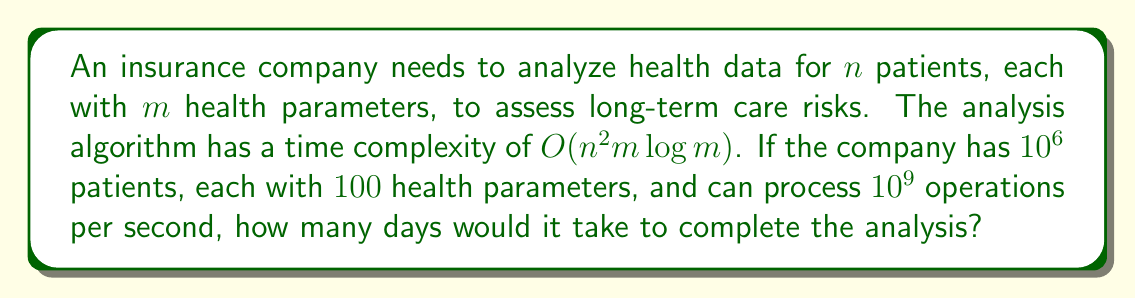Teach me how to tackle this problem. Let's approach this step-by-step:

1) We are given:
   - Number of patients, $n = 10^6$
   - Number of health parameters per patient, $m = 100$
   - Processing speed = $10^9$ operations per second

2) The time complexity is $O(n^2m\log m)$. Let's calculate this:
   
   $$n^2 = (10^6)^2 = 10^{12}$$
   $$m\log m = 100 \log 100 \approx 100 \times 4.6 = 460$$
   
   So, the total number of operations is approximately:
   
   $$10^{12} \times 460 = 4.6 \times 10^{14}$$

3) Now, let's calculate how many seconds this will take:

   $$\text{Time (in seconds)} = \frac{4.6 \times 10^{14}}{10^9} = 4.6 \times 10^5$$

4) Convert seconds to days:
   
   $$\text{Time (in days)} = \frac{4.6 \times 10^5}{86400} \approx 5.32$$

   Where 86400 is the number of seconds in a day.

Thus, it would take approximately 5.32 days to complete the analysis.
Answer: 5.32 days 